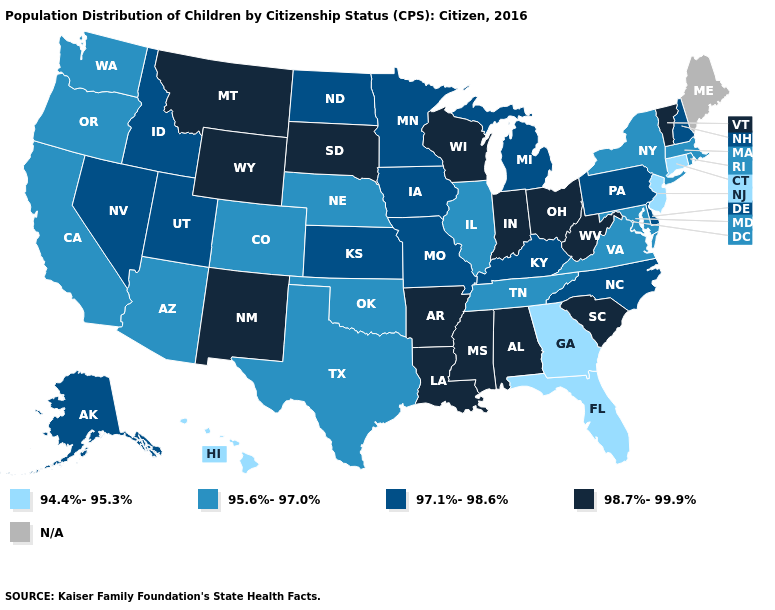Does South Carolina have the highest value in the South?
Answer briefly. Yes. What is the value of New York?
Keep it brief. 95.6%-97.0%. Name the states that have a value in the range 97.1%-98.6%?
Write a very short answer. Alaska, Delaware, Idaho, Iowa, Kansas, Kentucky, Michigan, Minnesota, Missouri, Nevada, New Hampshire, North Carolina, North Dakota, Pennsylvania, Utah. Which states have the lowest value in the USA?
Write a very short answer. Connecticut, Florida, Georgia, Hawaii, New Jersey. Among the states that border North Dakota , does Minnesota have the highest value?
Keep it brief. No. Name the states that have a value in the range 97.1%-98.6%?
Short answer required. Alaska, Delaware, Idaho, Iowa, Kansas, Kentucky, Michigan, Minnesota, Missouri, Nevada, New Hampshire, North Carolina, North Dakota, Pennsylvania, Utah. What is the value of Alaska?
Write a very short answer. 97.1%-98.6%. Which states have the lowest value in the USA?
Answer briefly. Connecticut, Florida, Georgia, Hawaii, New Jersey. Name the states that have a value in the range 97.1%-98.6%?
Be succinct. Alaska, Delaware, Idaho, Iowa, Kansas, Kentucky, Michigan, Minnesota, Missouri, Nevada, New Hampshire, North Carolina, North Dakota, Pennsylvania, Utah. What is the highest value in states that border Nevada?
Keep it brief. 97.1%-98.6%. What is the lowest value in the USA?
Be succinct. 94.4%-95.3%. What is the value of New Jersey?
Answer briefly. 94.4%-95.3%. What is the highest value in the MidWest ?
Give a very brief answer. 98.7%-99.9%. 